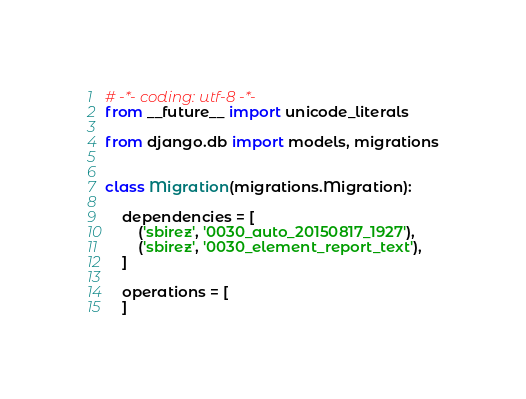<code> <loc_0><loc_0><loc_500><loc_500><_Python_># -*- coding: utf-8 -*-
from __future__ import unicode_literals

from django.db import models, migrations


class Migration(migrations.Migration):

    dependencies = [
        ('sbirez', '0030_auto_20150817_1927'),
        ('sbirez', '0030_element_report_text'),
    ]

    operations = [
    ]
</code> 